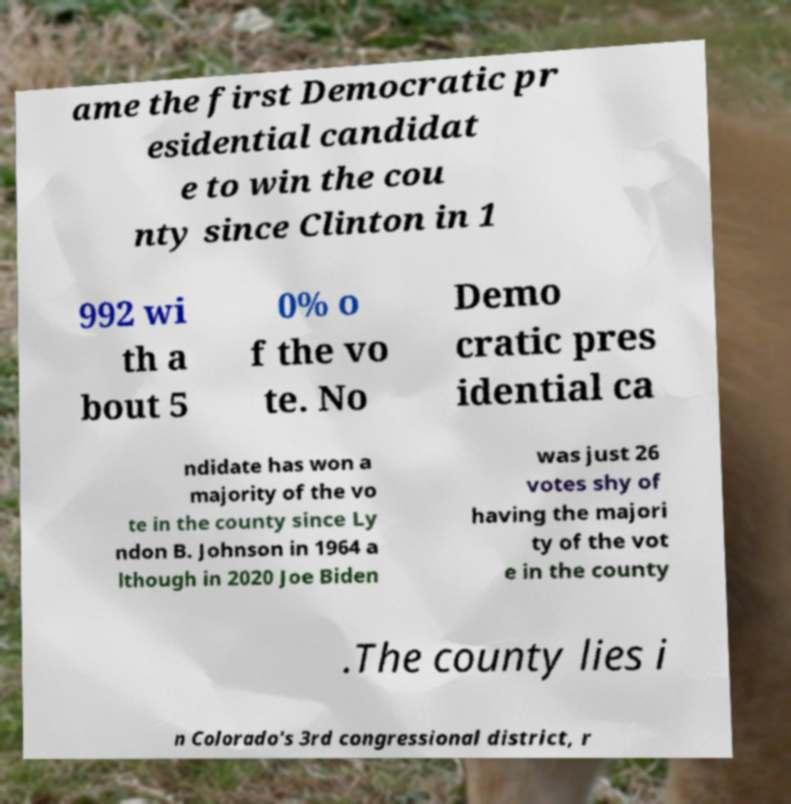I need the written content from this picture converted into text. Can you do that? ame the first Democratic pr esidential candidat e to win the cou nty since Clinton in 1 992 wi th a bout 5 0% o f the vo te. No Demo cratic pres idential ca ndidate has won a majority of the vo te in the county since Ly ndon B. Johnson in 1964 a lthough in 2020 Joe Biden was just 26 votes shy of having the majori ty of the vot e in the county .The county lies i n Colorado's 3rd congressional district, r 